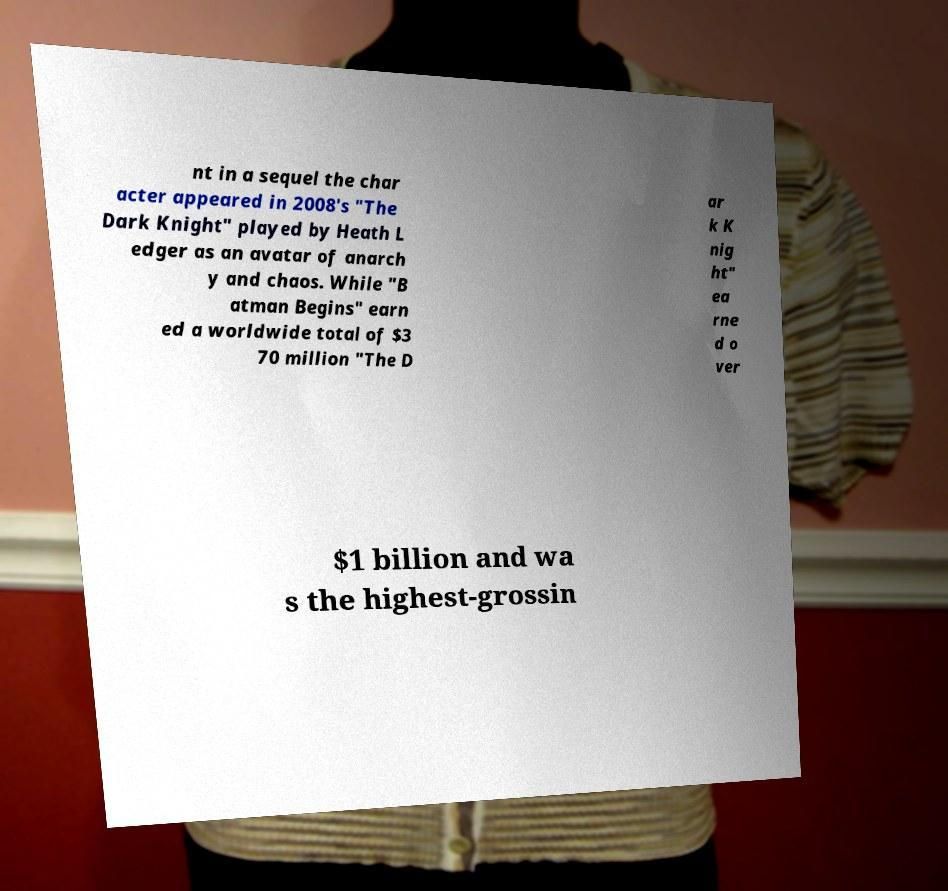Could you extract and type out the text from this image? nt in a sequel the char acter appeared in 2008's "The Dark Knight" played by Heath L edger as an avatar of anarch y and chaos. While "B atman Begins" earn ed a worldwide total of $3 70 million "The D ar k K nig ht" ea rne d o ver $1 billion and wa s the highest-grossin 